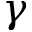<formula> <loc_0><loc_0><loc_500><loc_500>\gamma</formula> 